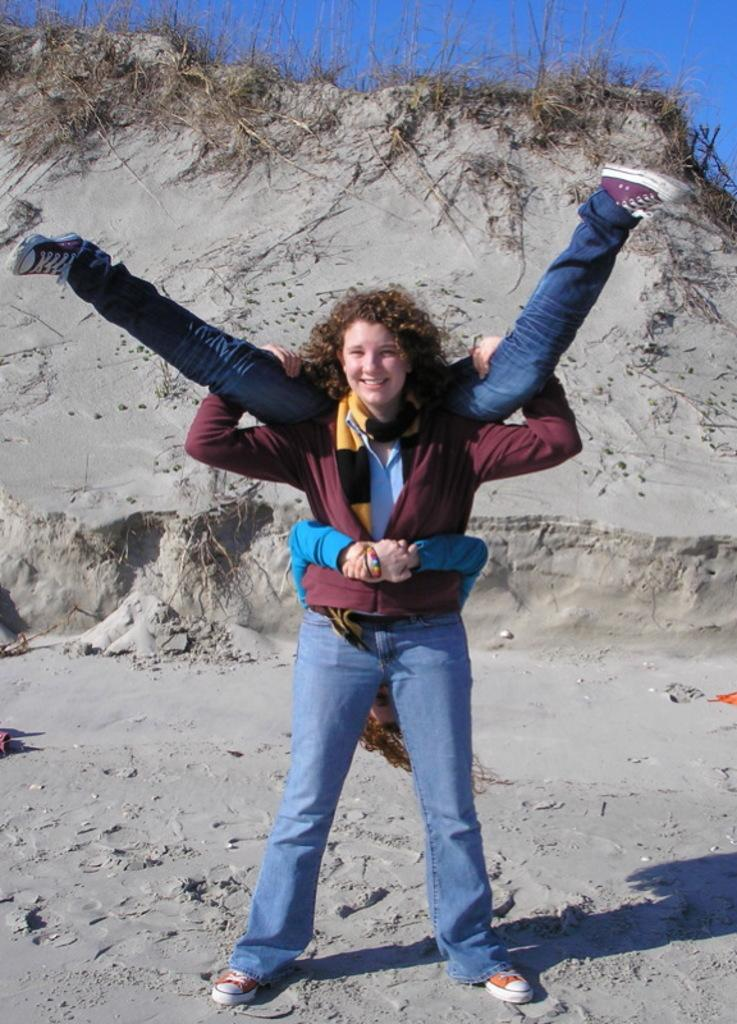What is the person in the image wearing? The person is wearing a maroon color jacket in the image. What is the person doing in the image? The person is lifting another person in the image. What type of surface are they standing on? They are standing on the sand in the image. What can be seen in the background of the image? There is grass and a blue sky visible in the background of the image. What type of drink is the stranger offering in the image? There is no stranger or drink present in the image. How does the person in the maroon jacket burst into flames in the image? The person in the maroon jacket does not burst into flames in the image; they are lifting another person on the sand. 